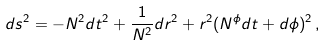Convert formula to latex. <formula><loc_0><loc_0><loc_500><loc_500>d s ^ { 2 } = - N ^ { 2 } d t ^ { 2 } + \frac { 1 } { N ^ { 2 } } d r ^ { 2 } + r ^ { 2 } ( N ^ { \phi } d t + d \phi ) ^ { 2 } \, ,</formula> 